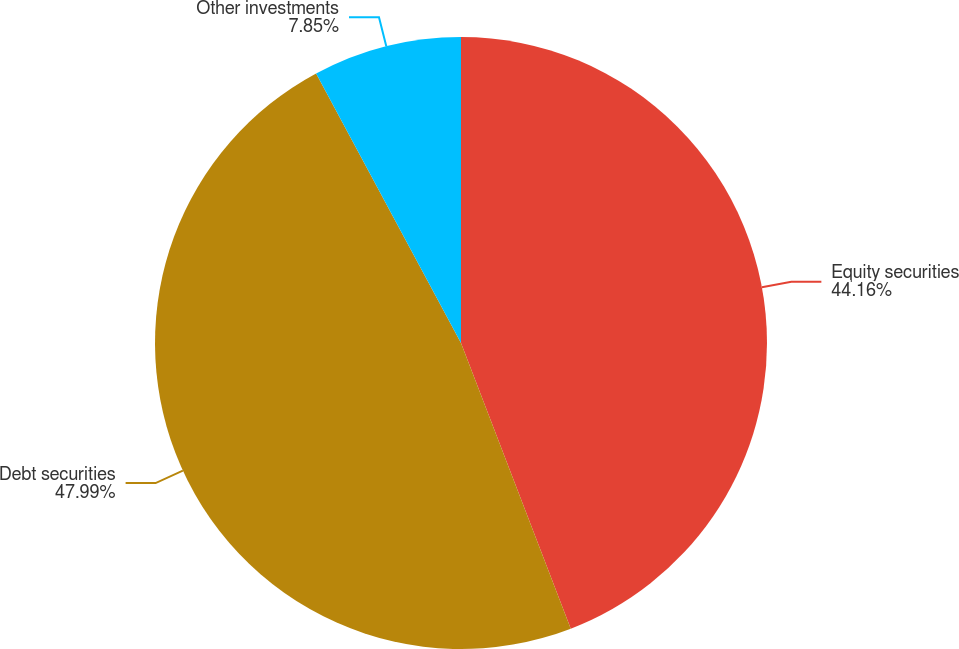<chart> <loc_0><loc_0><loc_500><loc_500><pie_chart><fcel>Equity securities<fcel>Debt securities<fcel>Other investments<nl><fcel>44.16%<fcel>47.99%<fcel>7.85%<nl></chart> 